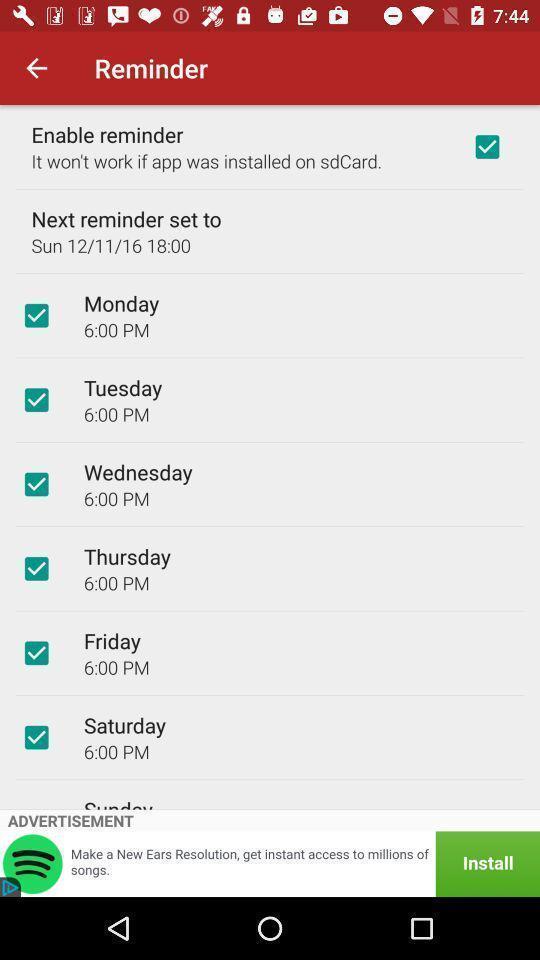Provide a textual representation of this image. Page displaying the reminders in a fitness app. 